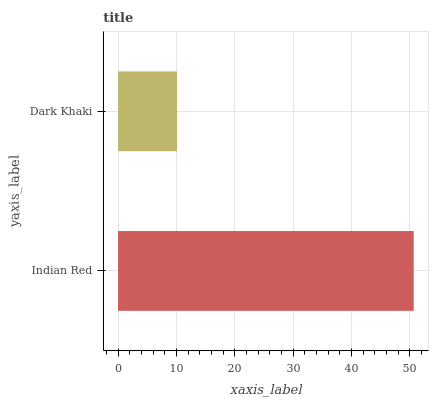Is Dark Khaki the minimum?
Answer yes or no. Yes. Is Indian Red the maximum?
Answer yes or no. Yes. Is Dark Khaki the maximum?
Answer yes or no. No. Is Indian Red greater than Dark Khaki?
Answer yes or no. Yes. Is Dark Khaki less than Indian Red?
Answer yes or no. Yes. Is Dark Khaki greater than Indian Red?
Answer yes or no. No. Is Indian Red less than Dark Khaki?
Answer yes or no. No. Is Indian Red the high median?
Answer yes or no. Yes. Is Dark Khaki the low median?
Answer yes or no. Yes. Is Dark Khaki the high median?
Answer yes or no. No. Is Indian Red the low median?
Answer yes or no. No. 